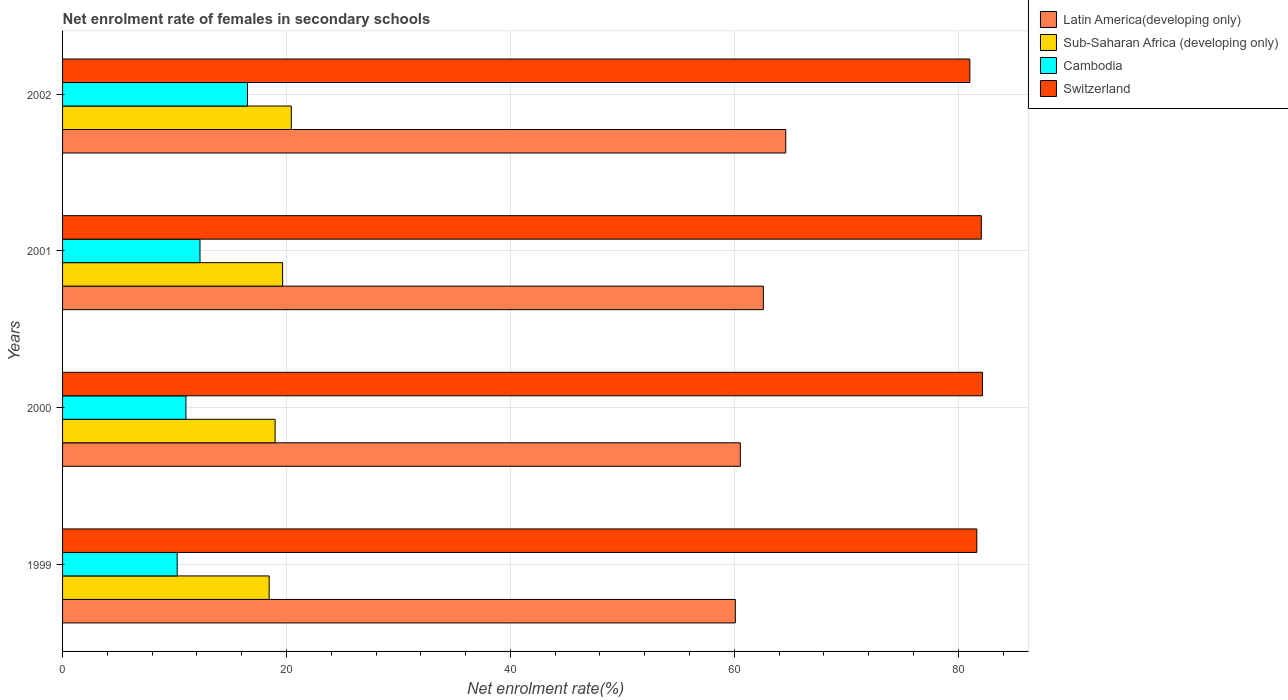How many different coloured bars are there?
Make the answer very short. 4. How many groups of bars are there?
Keep it short and to the point. 4. Are the number of bars per tick equal to the number of legend labels?
Give a very brief answer. Yes. What is the label of the 4th group of bars from the top?
Keep it short and to the point. 1999. What is the net enrolment rate of females in secondary schools in Switzerland in 2001?
Make the answer very short. 82.06. Across all years, what is the maximum net enrolment rate of females in secondary schools in Latin America(developing only)?
Your response must be concise. 64.59. Across all years, what is the minimum net enrolment rate of females in secondary schools in Sub-Saharan Africa (developing only)?
Your response must be concise. 18.45. What is the total net enrolment rate of females in secondary schools in Switzerland in the graph?
Offer a very short reply. 326.91. What is the difference between the net enrolment rate of females in secondary schools in Sub-Saharan Africa (developing only) in 1999 and that in 2000?
Keep it short and to the point. -0.53. What is the difference between the net enrolment rate of females in secondary schools in Sub-Saharan Africa (developing only) in 1999 and the net enrolment rate of females in secondary schools in Cambodia in 2001?
Your response must be concise. 6.18. What is the average net enrolment rate of females in secondary schools in Latin America(developing only) per year?
Your answer should be compact. 61.95. In the year 2002, what is the difference between the net enrolment rate of females in secondary schools in Latin America(developing only) and net enrolment rate of females in secondary schools in Sub-Saharan Africa (developing only)?
Offer a very short reply. 44.16. What is the ratio of the net enrolment rate of females in secondary schools in Switzerland in 1999 to that in 2002?
Provide a short and direct response. 1.01. Is the net enrolment rate of females in secondary schools in Cambodia in 1999 less than that in 2001?
Make the answer very short. Yes. What is the difference between the highest and the second highest net enrolment rate of females in secondary schools in Latin America(developing only)?
Give a very brief answer. 2. What is the difference between the highest and the lowest net enrolment rate of females in secondary schools in Latin America(developing only)?
Give a very brief answer. 4.5. Is the sum of the net enrolment rate of females in secondary schools in Sub-Saharan Africa (developing only) in 2001 and 2002 greater than the maximum net enrolment rate of females in secondary schools in Switzerland across all years?
Your answer should be very brief. No. Is it the case that in every year, the sum of the net enrolment rate of females in secondary schools in Cambodia and net enrolment rate of females in secondary schools in Sub-Saharan Africa (developing only) is greater than the sum of net enrolment rate of females in secondary schools in Latin America(developing only) and net enrolment rate of females in secondary schools in Switzerland?
Provide a short and direct response. No. What does the 1st bar from the top in 2002 represents?
Ensure brevity in your answer.  Switzerland. What does the 3rd bar from the bottom in 2001 represents?
Keep it short and to the point. Cambodia. What is the difference between two consecutive major ticks on the X-axis?
Offer a terse response. 20. Where does the legend appear in the graph?
Give a very brief answer. Top right. How many legend labels are there?
Offer a very short reply. 4. How are the legend labels stacked?
Offer a terse response. Vertical. What is the title of the graph?
Provide a succinct answer. Net enrolment rate of females in secondary schools. Does "Saudi Arabia" appear as one of the legend labels in the graph?
Offer a very short reply. No. What is the label or title of the X-axis?
Ensure brevity in your answer.  Net enrolment rate(%). What is the label or title of the Y-axis?
Keep it short and to the point. Years. What is the Net enrolment rate(%) of Latin America(developing only) in 1999?
Your answer should be very brief. 60.09. What is the Net enrolment rate(%) in Sub-Saharan Africa (developing only) in 1999?
Offer a very short reply. 18.45. What is the Net enrolment rate(%) in Cambodia in 1999?
Offer a terse response. 10.24. What is the Net enrolment rate(%) in Switzerland in 1999?
Provide a succinct answer. 81.66. What is the Net enrolment rate(%) in Latin America(developing only) in 2000?
Keep it short and to the point. 60.53. What is the Net enrolment rate(%) of Sub-Saharan Africa (developing only) in 2000?
Your answer should be very brief. 18.99. What is the Net enrolment rate(%) in Cambodia in 2000?
Your answer should be very brief. 11.02. What is the Net enrolment rate(%) of Switzerland in 2000?
Your response must be concise. 82.16. What is the Net enrolment rate(%) of Latin America(developing only) in 2001?
Your answer should be compact. 62.59. What is the Net enrolment rate(%) in Sub-Saharan Africa (developing only) in 2001?
Provide a succinct answer. 19.66. What is the Net enrolment rate(%) in Cambodia in 2001?
Your answer should be very brief. 12.27. What is the Net enrolment rate(%) of Switzerland in 2001?
Provide a succinct answer. 82.06. What is the Net enrolment rate(%) in Latin America(developing only) in 2002?
Offer a terse response. 64.59. What is the Net enrolment rate(%) in Sub-Saharan Africa (developing only) in 2002?
Make the answer very short. 20.43. What is the Net enrolment rate(%) of Cambodia in 2002?
Make the answer very short. 16.52. What is the Net enrolment rate(%) of Switzerland in 2002?
Keep it short and to the point. 81.03. Across all years, what is the maximum Net enrolment rate(%) in Latin America(developing only)?
Offer a very short reply. 64.59. Across all years, what is the maximum Net enrolment rate(%) of Sub-Saharan Africa (developing only)?
Make the answer very short. 20.43. Across all years, what is the maximum Net enrolment rate(%) in Cambodia?
Make the answer very short. 16.52. Across all years, what is the maximum Net enrolment rate(%) of Switzerland?
Provide a succinct answer. 82.16. Across all years, what is the minimum Net enrolment rate(%) of Latin America(developing only)?
Keep it short and to the point. 60.09. Across all years, what is the minimum Net enrolment rate(%) of Sub-Saharan Africa (developing only)?
Make the answer very short. 18.45. Across all years, what is the minimum Net enrolment rate(%) of Cambodia?
Give a very brief answer. 10.24. Across all years, what is the minimum Net enrolment rate(%) of Switzerland?
Ensure brevity in your answer.  81.03. What is the total Net enrolment rate(%) of Latin America(developing only) in the graph?
Your response must be concise. 247.81. What is the total Net enrolment rate(%) in Sub-Saharan Africa (developing only) in the graph?
Your answer should be compact. 77.52. What is the total Net enrolment rate(%) of Cambodia in the graph?
Ensure brevity in your answer.  50.05. What is the total Net enrolment rate(%) in Switzerland in the graph?
Give a very brief answer. 326.91. What is the difference between the Net enrolment rate(%) of Latin America(developing only) in 1999 and that in 2000?
Keep it short and to the point. -0.45. What is the difference between the Net enrolment rate(%) of Sub-Saharan Africa (developing only) in 1999 and that in 2000?
Your response must be concise. -0.53. What is the difference between the Net enrolment rate(%) in Cambodia in 1999 and that in 2000?
Offer a very short reply. -0.78. What is the difference between the Net enrolment rate(%) of Switzerland in 1999 and that in 2000?
Your response must be concise. -0.5. What is the difference between the Net enrolment rate(%) in Latin America(developing only) in 1999 and that in 2001?
Provide a succinct answer. -2.5. What is the difference between the Net enrolment rate(%) of Sub-Saharan Africa (developing only) in 1999 and that in 2001?
Offer a terse response. -1.2. What is the difference between the Net enrolment rate(%) in Cambodia in 1999 and that in 2001?
Provide a short and direct response. -2.04. What is the difference between the Net enrolment rate(%) in Switzerland in 1999 and that in 2001?
Your response must be concise. -0.4. What is the difference between the Net enrolment rate(%) in Latin America(developing only) in 1999 and that in 2002?
Provide a succinct answer. -4.5. What is the difference between the Net enrolment rate(%) in Sub-Saharan Africa (developing only) in 1999 and that in 2002?
Provide a succinct answer. -1.98. What is the difference between the Net enrolment rate(%) of Cambodia in 1999 and that in 2002?
Your answer should be compact. -6.28. What is the difference between the Net enrolment rate(%) of Switzerland in 1999 and that in 2002?
Provide a short and direct response. 0.62. What is the difference between the Net enrolment rate(%) of Latin America(developing only) in 2000 and that in 2001?
Keep it short and to the point. -2.06. What is the difference between the Net enrolment rate(%) in Sub-Saharan Africa (developing only) in 2000 and that in 2001?
Provide a succinct answer. -0.67. What is the difference between the Net enrolment rate(%) of Cambodia in 2000 and that in 2001?
Offer a terse response. -1.25. What is the difference between the Net enrolment rate(%) of Switzerland in 2000 and that in 2001?
Provide a short and direct response. 0.1. What is the difference between the Net enrolment rate(%) of Latin America(developing only) in 2000 and that in 2002?
Ensure brevity in your answer.  -4.06. What is the difference between the Net enrolment rate(%) in Sub-Saharan Africa (developing only) in 2000 and that in 2002?
Provide a succinct answer. -1.45. What is the difference between the Net enrolment rate(%) of Cambodia in 2000 and that in 2002?
Provide a short and direct response. -5.5. What is the difference between the Net enrolment rate(%) in Switzerland in 2000 and that in 2002?
Keep it short and to the point. 1.13. What is the difference between the Net enrolment rate(%) of Latin America(developing only) in 2001 and that in 2002?
Provide a succinct answer. -2. What is the difference between the Net enrolment rate(%) in Sub-Saharan Africa (developing only) in 2001 and that in 2002?
Offer a terse response. -0.78. What is the difference between the Net enrolment rate(%) in Cambodia in 2001 and that in 2002?
Offer a terse response. -4.24. What is the difference between the Net enrolment rate(%) of Switzerland in 2001 and that in 2002?
Your answer should be very brief. 1.02. What is the difference between the Net enrolment rate(%) in Latin America(developing only) in 1999 and the Net enrolment rate(%) in Sub-Saharan Africa (developing only) in 2000?
Offer a terse response. 41.1. What is the difference between the Net enrolment rate(%) in Latin America(developing only) in 1999 and the Net enrolment rate(%) in Cambodia in 2000?
Offer a terse response. 49.07. What is the difference between the Net enrolment rate(%) of Latin America(developing only) in 1999 and the Net enrolment rate(%) of Switzerland in 2000?
Ensure brevity in your answer.  -22.07. What is the difference between the Net enrolment rate(%) in Sub-Saharan Africa (developing only) in 1999 and the Net enrolment rate(%) in Cambodia in 2000?
Your answer should be compact. 7.43. What is the difference between the Net enrolment rate(%) in Sub-Saharan Africa (developing only) in 1999 and the Net enrolment rate(%) in Switzerland in 2000?
Keep it short and to the point. -63.71. What is the difference between the Net enrolment rate(%) in Cambodia in 1999 and the Net enrolment rate(%) in Switzerland in 2000?
Give a very brief answer. -71.92. What is the difference between the Net enrolment rate(%) of Latin America(developing only) in 1999 and the Net enrolment rate(%) of Sub-Saharan Africa (developing only) in 2001?
Keep it short and to the point. 40.43. What is the difference between the Net enrolment rate(%) in Latin America(developing only) in 1999 and the Net enrolment rate(%) in Cambodia in 2001?
Make the answer very short. 47.81. What is the difference between the Net enrolment rate(%) of Latin America(developing only) in 1999 and the Net enrolment rate(%) of Switzerland in 2001?
Your answer should be compact. -21.97. What is the difference between the Net enrolment rate(%) in Sub-Saharan Africa (developing only) in 1999 and the Net enrolment rate(%) in Cambodia in 2001?
Offer a very short reply. 6.18. What is the difference between the Net enrolment rate(%) in Sub-Saharan Africa (developing only) in 1999 and the Net enrolment rate(%) in Switzerland in 2001?
Offer a very short reply. -63.61. What is the difference between the Net enrolment rate(%) in Cambodia in 1999 and the Net enrolment rate(%) in Switzerland in 2001?
Make the answer very short. -71.82. What is the difference between the Net enrolment rate(%) of Latin America(developing only) in 1999 and the Net enrolment rate(%) of Sub-Saharan Africa (developing only) in 2002?
Your answer should be very brief. 39.66. What is the difference between the Net enrolment rate(%) in Latin America(developing only) in 1999 and the Net enrolment rate(%) in Cambodia in 2002?
Offer a terse response. 43.57. What is the difference between the Net enrolment rate(%) in Latin America(developing only) in 1999 and the Net enrolment rate(%) in Switzerland in 2002?
Keep it short and to the point. -20.95. What is the difference between the Net enrolment rate(%) in Sub-Saharan Africa (developing only) in 1999 and the Net enrolment rate(%) in Cambodia in 2002?
Your response must be concise. 1.93. What is the difference between the Net enrolment rate(%) of Sub-Saharan Africa (developing only) in 1999 and the Net enrolment rate(%) of Switzerland in 2002?
Offer a terse response. -62.58. What is the difference between the Net enrolment rate(%) in Cambodia in 1999 and the Net enrolment rate(%) in Switzerland in 2002?
Offer a very short reply. -70.8. What is the difference between the Net enrolment rate(%) of Latin America(developing only) in 2000 and the Net enrolment rate(%) of Sub-Saharan Africa (developing only) in 2001?
Provide a succinct answer. 40.88. What is the difference between the Net enrolment rate(%) of Latin America(developing only) in 2000 and the Net enrolment rate(%) of Cambodia in 2001?
Your answer should be compact. 48.26. What is the difference between the Net enrolment rate(%) of Latin America(developing only) in 2000 and the Net enrolment rate(%) of Switzerland in 2001?
Give a very brief answer. -21.52. What is the difference between the Net enrolment rate(%) of Sub-Saharan Africa (developing only) in 2000 and the Net enrolment rate(%) of Cambodia in 2001?
Offer a very short reply. 6.71. What is the difference between the Net enrolment rate(%) of Sub-Saharan Africa (developing only) in 2000 and the Net enrolment rate(%) of Switzerland in 2001?
Offer a very short reply. -63.07. What is the difference between the Net enrolment rate(%) in Cambodia in 2000 and the Net enrolment rate(%) in Switzerland in 2001?
Offer a very short reply. -71.04. What is the difference between the Net enrolment rate(%) in Latin America(developing only) in 2000 and the Net enrolment rate(%) in Sub-Saharan Africa (developing only) in 2002?
Keep it short and to the point. 40.1. What is the difference between the Net enrolment rate(%) in Latin America(developing only) in 2000 and the Net enrolment rate(%) in Cambodia in 2002?
Make the answer very short. 44.02. What is the difference between the Net enrolment rate(%) in Latin America(developing only) in 2000 and the Net enrolment rate(%) in Switzerland in 2002?
Make the answer very short. -20.5. What is the difference between the Net enrolment rate(%) of Sub-Saharan Africa (developing only) in 2000 and the Net enrolment rate(%) of Cambodia in 2002?
Provide a short and direct response. 2.47. What is the difference between the Net enrolment rate(%) in Sub-Saharan Africa (developing only) in 2000 and the Net enrolment rate(%) in Switzerland in 2002?
Your answer should be very brief. -62.05. What is the difference between the Net enrolment rate(%) in Cambodia in 2000 and the Net enrolment rate(%) in Switzerland in 2002?
Your response must be concise. -70.01. What is the difference between the Net enrolment rate(%) in Latin America(developing only) in 2001 and the Net enrolment rate(%) in Sub-Saharan Africa (developing only) in 2002?
Your answer should be very brief. 42.16. What is the difference between the Net enrolment rate(%) of Latin America(developing only) in 2001 and the Net enrolment rate(%) of Cambodia in 2002?
Keep it short and to the point. 46.07. What is the difference between the Net enrolment rate(%) in Latin America(developing only) in 2001 and the Net enrolment rate(%) in Switzerland in 2002?
Give a very brief answer. -18.44. What is the difference between the Net enrolment rate(%) of Sub-Saharan Africa (developing only) in 2001 and the Net enrolment rate(%) of Cambodia in 2002?
Give a very brief answer. 3.14. What is the difference between the Net enrolment rate(%) in Sub-Saharan Africa (developing only) in 2001 and the Net enrolment rate(%) in Switzerland in 2002?
Provide a succinct answer. -61.38. What is the difference between the Net enrolment rate(%) of Cambodia in 2001 and the Net enrolment rate(%) of Switzerland in 2002?
Offer a very short reply. -68.76. What is the average Net enrolment rate(%) of Latin America(developing only) per year?
Give a very brief answer. 61.95. What is the average Net enrolment rate(%) in Sub-Saharan Africa (developing only) per year?
Your answer should be very brief. 19.38. What is the average Net enrolment rate(%) of Cambodia per year?
Give a very brief answer. 12.51. What is the average Net enrolment rate(%) of Switzerland per year?
Offer a terse response. 81.73. In the year 1999, what is the difference between the Net enrolment rate(%) of Latin America(developing only) and Net enrolment rate(%) of Sub-Saharan Africa (developing only)?
Your response must be concise. 41.64. In the year 1999, what is the difference between the Net enrolment rate(%) of Latin America(developing only) and Net enrolment rate(%) of Cambodia?
Keep it short and to the point. 49.85. In the year 1999, what is the difference between the Net enrolment rate(%) in Latin America(developing only) and Net enrolment rate(%) in Switzerland?
Your answer should be compact. -21.57. In the year 1999, what is the difference between the Net enrolment rate(%) of Sub-Saharan Africa (developing only) and Net enrolment rate(%) of Cambodia?
Provide a succinct answer. 8.21. In the year 1999, what is the difference between the Net enrolment rate(%) of Sub-Saharan Africa (developing only) and Net enrolment rate(%) of Switzerland?
Provide a succinct answer. -63.2. In the year 1999, what is the difference between the Net enrolment rate(%) in Cambodia and Net enrolment rate(%) in Switzerland?
Ensure brevity in your answer.  -71.42. In the year 2000, what is the difference between the Net enrolment rate(%) in Latin America(developing only) and Net enrolment rate(%) in Sub-Saharan Africa (developing only)?
Make the answer very short. 41.55. In the year 2000, what is the difference between the Net enrolment rate(%) in Latin America(developing only) and Net enrolment rate(%) in Cambodia?
Keep it short and to the point. 49.51. In the year 2000, what is the difference between the Net enrolment rate(%) of Latin America(developing only) and Net enrolment rate(%) of Switzerland?
Give a very brief answer. -21.63. In the year 2000, what is the difference between the Net enrolment rate(%) in Sub-Saharan Africa (developing only) and Net enrolment rate(%) in Cambodia?
Make the answer very short. 7.96. In the year 2000, what is the difference between the Net enrolment rate(%) of Sub-Saharan Africa (developing only) and Net enrolment rate(%) of Switzerland?
Provide a short and direct response. -63.18. In the year 2000, what is the difference between the Net enrolment rate(%) of Cambodia and Net enrolment rate(%) of Switzerland?
Keep it short and to the point. -71.14. In the year 2001, what is the difference between the Net enrolment rate(%) in Latin America(developing only) and Net enrolment rate(%) in Sub-Saharan Africa (developing only)?
Provide a succinct answer. 42.94. In the year 2001, what is the difference between the Net enrolment rate(%) in Latin America(developing only) and Net enrolment rate(%) in Cambodia?
Your answer should be compact. 50.32. In the year 2001, what is the difference between the Net enrolment rate(%) in Latin America(developing only) and Net enrolment rate(%) in Switzerland?
Your response must be concise. -19.47. In the year 2001, what is the difference between the Net enrolment rate(%) in Sub-Saharan Africa (developing only) and Net enrolment rate(%) in Cambodia?
Give a very brief answer. 7.38. In the year 2001, what is the difference between the Net enrolment rate(%) of Sub-Saharan Africa (developing only) and Net enrolment rate(%) of Switzerland?
Your answer should be compact. -62.4. In the year 2001, what is the difference between the Net enrolment rate(%) in Cambodia and Net enrolment rate(%) in Switzerland?
Offer a very short reply. -69.78. In the year 2002, what is the difference between the Net enrolment rate(%) of Latin America(developing only) and Net enrolment rate(%) of Sub-Saharan Africa (developing only)?
Keep it short and to the point. 44.16. In the year 2002, what is the difference between the Net enrolment rate(%) in Latin America(developing only) and Net enrolment rate(%) in Cambodia?
Keep it short and to the point. 48.07. In the year 2002, what is the difference between the Net enrolment rate(%) in Latin America(developing only) and Net enrolment rate(%) in Switzerland?
Give a very brief answer. -16.44. In the year 2002, what is the difference between the Net enrolment rate(%) in Sub-Saharan Africa (developing only) and Net enrolment rate(%) in Cambodia?
Ensure brevity in your answer.  3.91. In the year 2002, what is the difference between the Net enrolment rate(%) of Sub-Saharan Africa (developing only) and Net enrolment rate(%) of Switzerland?
Your answer should be very brief. -60.6. In the year 2002, what is the difference between the Net enrolment rate(%) in Cambodia and Net enrolment rate(%) in Switzerland?
Offer a very short reply. -64.52. What is the ratio of the Net enrolment rate(%) of Sub-Saharan Africa (developing only) in 1999 to that in 2000?
Offer a very short reply. 0.97. What is the ratio of the Net enrolment rate(%) in Cambodia in 1999 to that in 2000?
Your answer should be compact. 0.93. What is the ratio of the Net enrolment rate(%) in Switzerland in 1999 to that in 2000?
Offer a terse response. 0.99. What is the ratio of the Net enrolment rate(%) of Sub-Saharan Africa (developing only) in 1999 to that in 2001?
Your answer should be very brief. 0.94. What is the ratio of the Net enrolment rate(%) in Cambodia in 1999 to that in 2001?
Offer a terse response. 0.83. What is the ratio of the Net enrolment rate(%) in Latin America(developing only) in 1999 to that in 2002?
Offer a terse response. 0.93. What is the ratio of the Net enrolment rate(%) of Sub-Saharan Africa (developing only) in 1999 to that in 2002?
Give a very brief answer. 0.9. What is the ratio of the Net enrolment rate(%) in Cambodia in 1999 to that in 2002?
Provide a short and direct response. 0.62. What is the ratio of the Net enrolment rate(%) in Switzerland in 1999 to that in 2002?
Ensure brevity in your answer.  1.01. What is the ratio of the Net enrolment rate(%) of Latin America(developing only) in 2000 to that in 2001?
Offer a terse response. 0.97. What is the ratio of the Net enrolment rate(%) in Sub-Saharan Africa (developing only) in 2000 to that in 2001?
Keep it short and to the point. 0.97. What is the ratio of the Net enrolment rate(%) of Cambodia in 2000 to that in 2001?
Your answer should be very brief. 0.9. What is the ratio of the Net enrolment rate(%) of Latin America(developing only) in 2000 to that in 2002?
Provide a succinct answer. 0.94. What is the ratio of the Net enrolment rate(%) in Sub-Saharan Africa (developing only) in 2000 to that in 2002?
Keep it short and to the point. 0.93. What is the ratio of the Net enrolment rate(%) of Cambodia in 2000 to that in 2002?
Offer a very short reply. 0.67. What is the ratio of the Net enrolment rate(%) of Switzerland in 2000 to that in 2002?
Provide a succinct answer. 1.01. What is the ratio of the Net enrolment rate(%) in Latin America(developing only) in 2001 to that in 2002?
Offer a very short reply. 0.97. What is the ratio of the Net enrolment rate(%) of Sub-Saharan Africa (developing only) in 2001 to that in 2002?
Ensure brevity in your answer.  0.96. What is the ratio of the Net enrolment rate(%) in Cambodia in 2001 to that in 2002?
Your response must be concise. 0.74. What is the ratio of the Net enrolment rate(%) of Switzerland in 2001 to that in 2002?
Keep it short and to the point. 1.01. What is the difference between the highest and the second highest Net enrolment rate(%) of Latin America(developing only)?
Ensure brevity in your answer.  2. What is the difference between the highest and the second highest Net enrolment rate(%) in Sub-Saharan Africa (developing only)?
Ensure brevity in your answer.  0.78. What is the difference between the highest and the second highest Net enrolment rate(%) of Cambodia?
Keep it short and to the point. 4.24. What is the difference between the highest and the second highest Net enrolment rate(%) in Switzerland?
Ensure brevity in your answer.  0.1. What is the difference between the highest and the lowest Net enrolment rate(%) in Latin America(developing only)?
Provide a short and direct response. 4.5. What is the difference between the highest and the lowest Net enrolment rate(%) in Sub-Saharan Africa (developing only)?
Provide a short and direct response. 1.98. What is the difference between the highest and the lowest Net enrolment rate(%) in Cambodia?
Your answer should be very brief. 6.28. What is the difference between the highest and the lowest Net enrolment rate(%) in Switzerland?
Give a very brief answer. 1.13. 